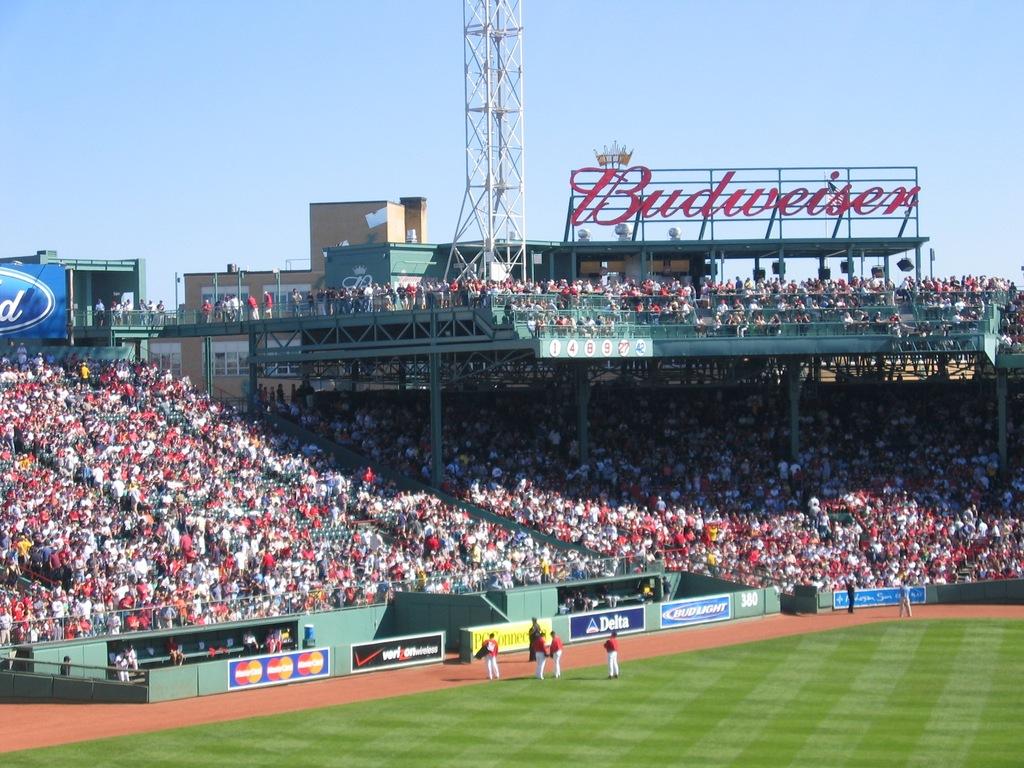What beer brand is advertised above the stands?
Offer a terse response. Budweiser. 